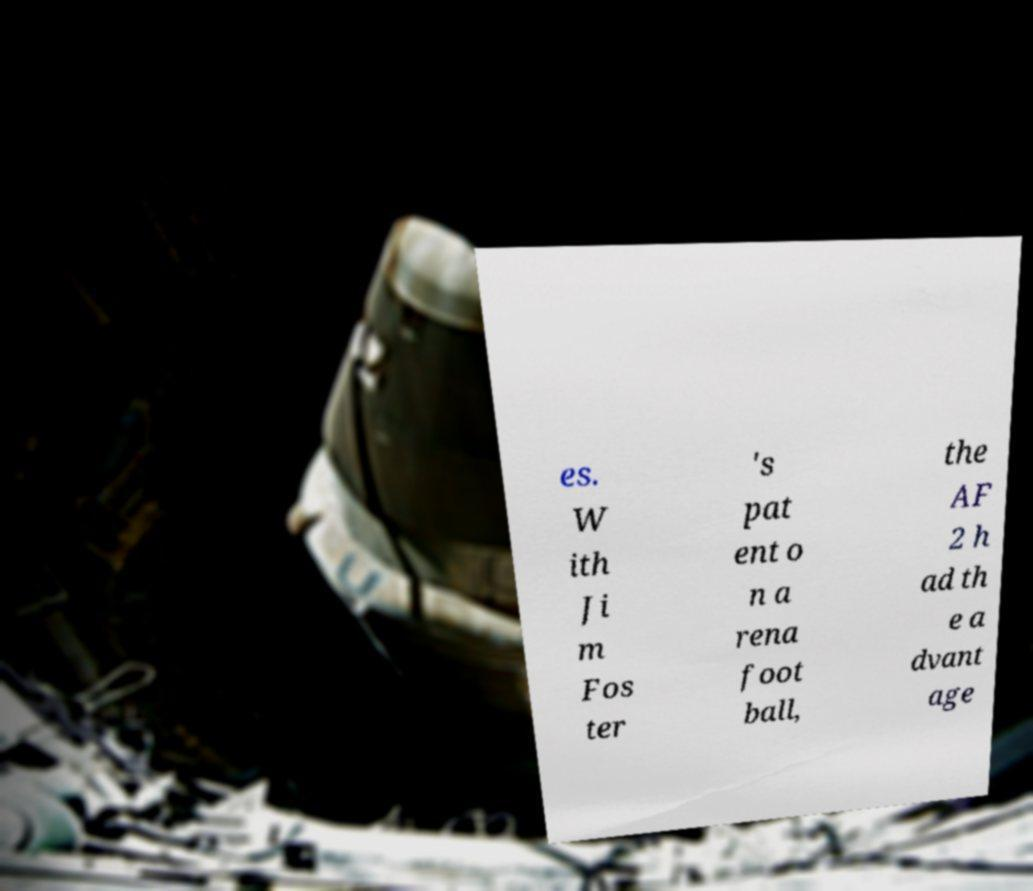Can you read and provide the text displayed in the image?This photo seems to have some interesting text. Can you extract and type it out for me? es. W ith Ji m Fos ter 's pat ent o n a rena foot ball, the AF 2 h ad th e a dvant age 